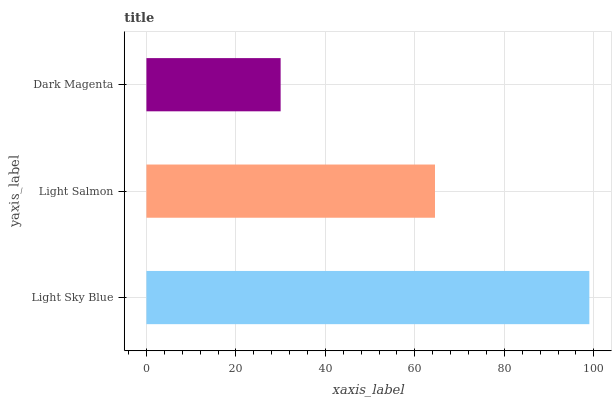Is Dark Magenta the minimum?
Answer yes or no. Yes. Is Light Sky Blue the maximum?
Answer yes or no. Yes. Is Light Salmon the minimum?
Answer yes or no. No. Is Light Salmon the maximum?
Answer yes or no. No. Is Light Sky Blue greater than Light Salmon?
Answer yes or no. Yes. Is Light Salmon less than Light Sky Blue?
Answer yes or no. Yes. Is Light Salmon greater than Light Sky Blue?
Answer yes or no. No. Is Light Sky Blue less than Light Salmon?
Answer yes or no. No. Is Light Salmon the high median?
Answer yes or no. Yes. Is Light Salmon the low median?
Answer yes or no. Yes. Is Dark Magenta the high median?
Answer yes or no. No. Is Dark Magenta the low median?
Answer yes or no. No. 